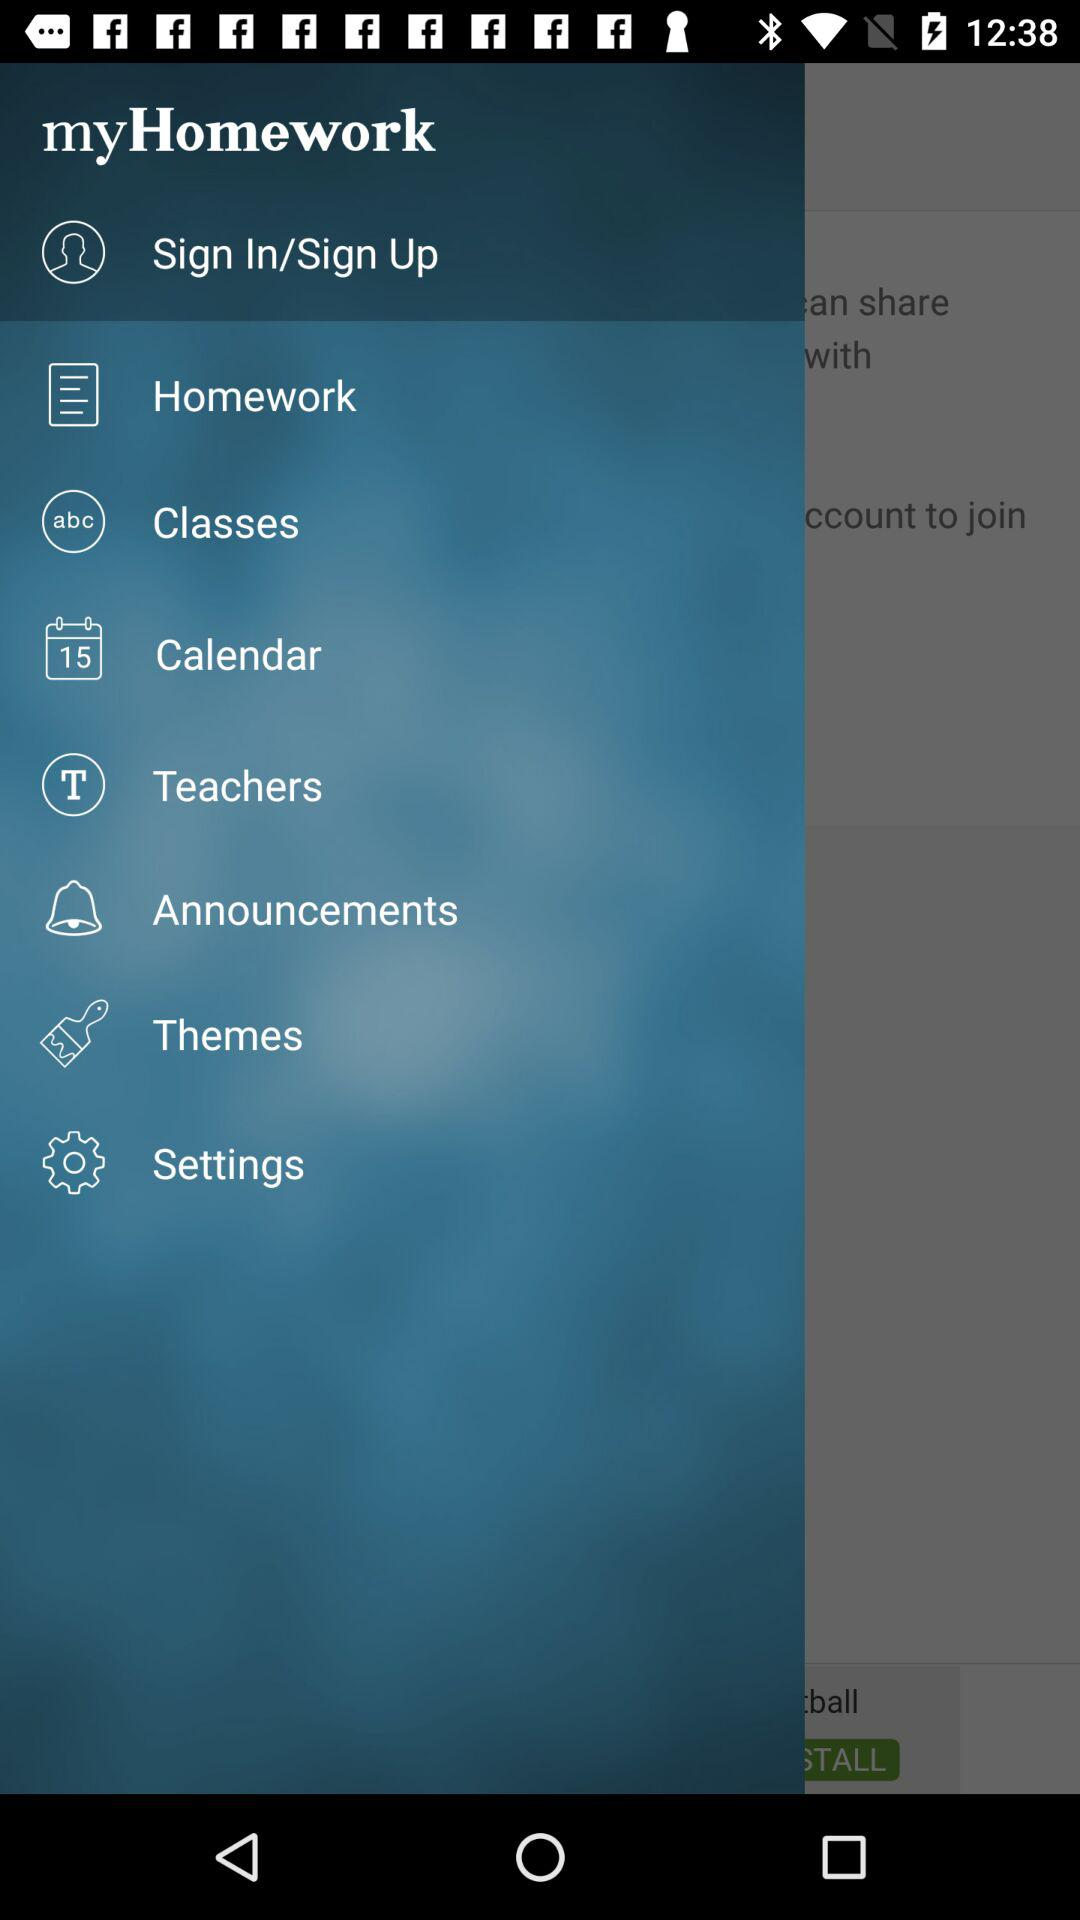Which classes are selected?
When the provided information is insufficient, respond with <no answer>. <no answer> 